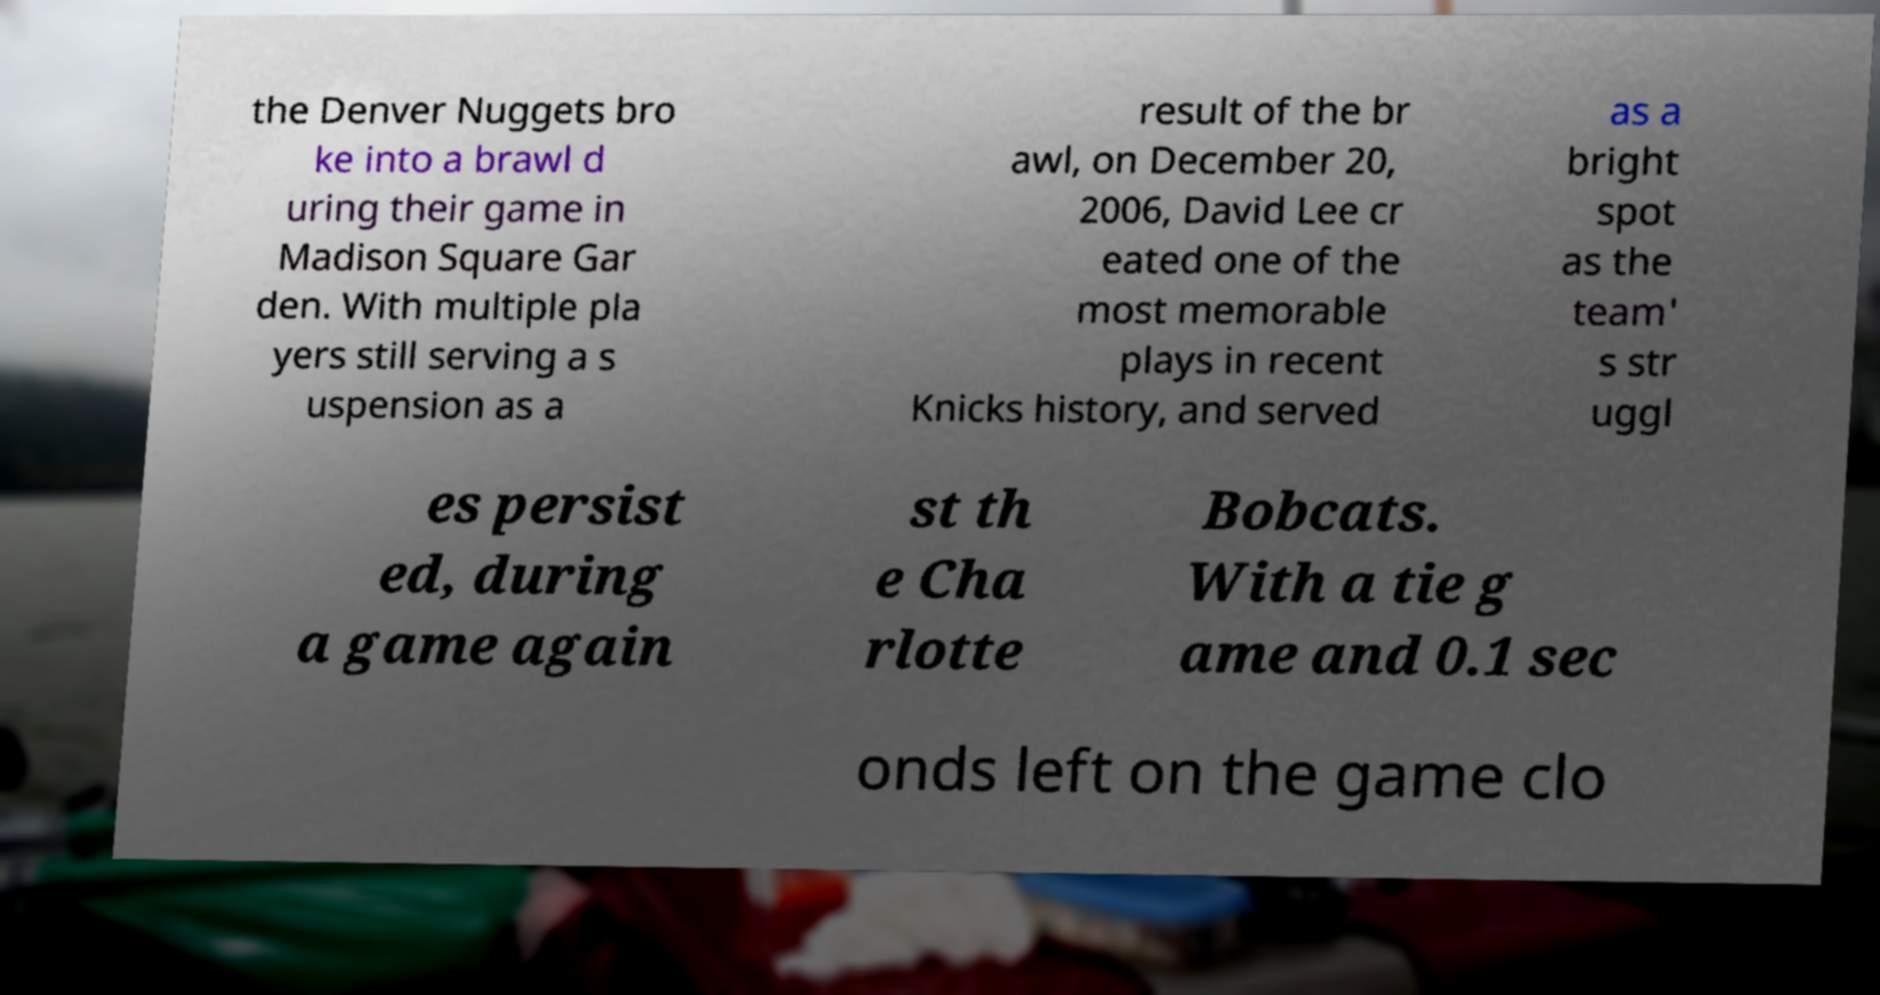Could you extract and type out the text from this image? the Denver Nuggets bro ke into a brawl d uring their game in Madison Square Gar den. With multiple pla yers still serving a s uspension as a result of the br awl, on December 20, 2006, David Lee cr eated one of the most memorable plays in recent Knicks history, and served as a bright spot as the team' s str uggl es persist ed, during a game again st th e Cha rlotte Bobcats. With a tie g ame and 0.1 sec onds left on the game clo 